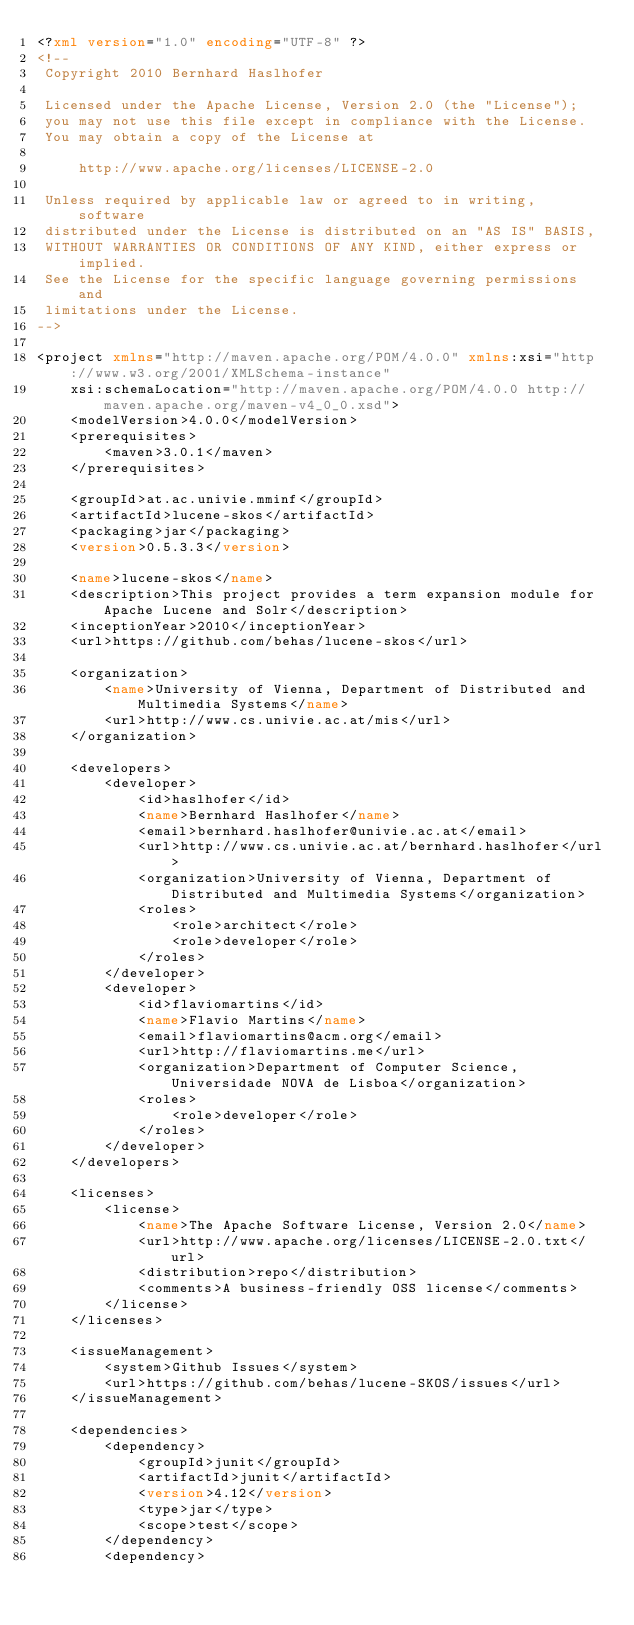<code> <loc_0><loc_0><loc_500><loc_500><_XML_><?xml version="1.0" encoding="UTF-8" ?>
<!--
 Copyright 2010 Bernhard Haslhofer 

 Licensed under the Apache License, Version 2.0 (the "License");
 you may not use this file except in compliance with the License.
 You may obtain a copy of the License at

     http://www.apache.org/licenses/LICENSE-2.0

 Unless required by applicable law or agreed to in writing, software
 distributed under the License is distributed on an "AS IS" BASIS,
 WITHOUT WARRANTIES OR CONDITIONS OF ANY KIND, either express or implied.
 See the License for the specific language governing permissions and
 limitations under the License.
-->

<project xmlns="http://maven.apache.org/POM/4.0.0" xmlns:xsi="http://www.w3.org/2001/XMLSchema-instance"
    xsi:schemaLocation="http://maven.apache.org/POM/4.0.0 http://maven.apache.org/maven-v4_0_0.xsd">
    <modelVersion>4.0.0</modelVersion>
    <prerequisites>
        <maven>3.0.1</maven>
    </prerequisites>
    
    <groupId>at.ac.univie.mminf</groupId>
    <artifactId>lucene-skos</artifactId>
    <packaging>jar</packaging>
    <version>0.5.3.3</version>

    <name>lucene-skos</name>
    <description>This project provides a term expansion module for Apache Lucene and Solr</description>
    <inceptionYear>2010</inceptionYear>
    <url>https://github.com/behas/lucene-skos</url>

    <organization>
        <name>University of Vienna, Department of Distributed and Multimedia Systems</name>
        <url>http://www.cs.univie.ac.at/mis</url>
    </organization>

    <developers>
        <developer>
            <id>haslhofer</id>
            <name>Bernhard Haslhofer</name>
            <email>bernhard.haslhofer@univie.ac.at</email>
            <url>http://www.cs.univie.ac.at/bernhard.haslhofer</url>
            <organization>University of Vienna, Department of Distributed and Multimedia Systems</organization>
            <roles>
                <role>architect</role>
                <role>developer</role>
            </roles>
        </developer>
        <developer>
            <id>flaviomartins</id>
            <name>Flavio Martins</name>
            <email>flaviomartins@acm.org</email>
            <url>http://flaviomartins.me</url>
            <organization>Department of Computer Science, Universidade NOVA de Lisboa</organization>
            <roles>
                <role>developer</role>
            </roles>
        </developer>
    </developers>

    <licenses>
        <license>
            <name>The Apache Software License, Version 2.0</name>
            <url>http://www.apache.org/licenses/LICENSE-2.0.txt</url>
            <distribution>repo</distribution>
            <comments>A business-friendly OSS license</comments>
        </license>
    </licenses>

    <issueManagement>
        <system>Github Issues</system>
        <url>https://github.com/behas/lucene-SKOS/issues</url>
    </issueManagement>

    <dependencies>
        <dependency>
            <groupId>junit</groupId>
            <artifactId>junit</artifactId>
            <version>4.12</version>
            <type>jar</type>
            <scope>test</scope>
        </dependency>
        <dependency></code> 